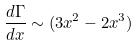Convert formula to latex. <formula><loc_0><loc_0><loc_500><loc_500>\frac { d \Gamma } { d x } \sim ( 3 x ^ { 2 } - 2 x ^ { 3 } )</formula> 